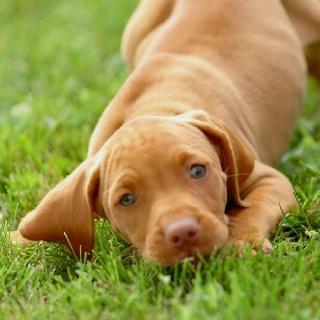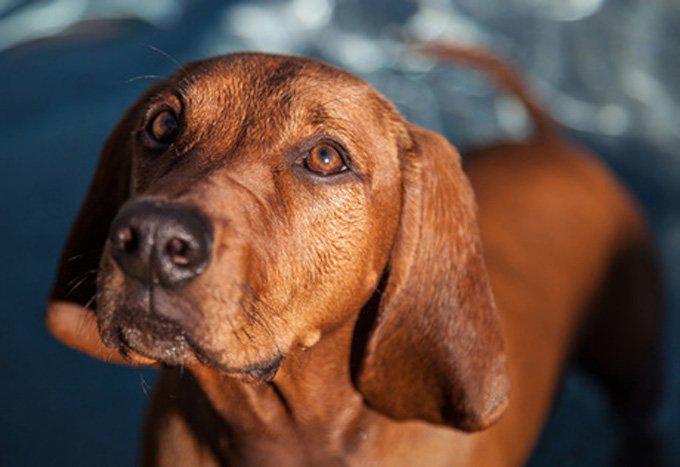The first image is the image on the left, the second image is the image on the right. Given the left and right images, does the statement "The dog in one of the images is lying down on the grass." hold true? Answer yes or no. Yes. 